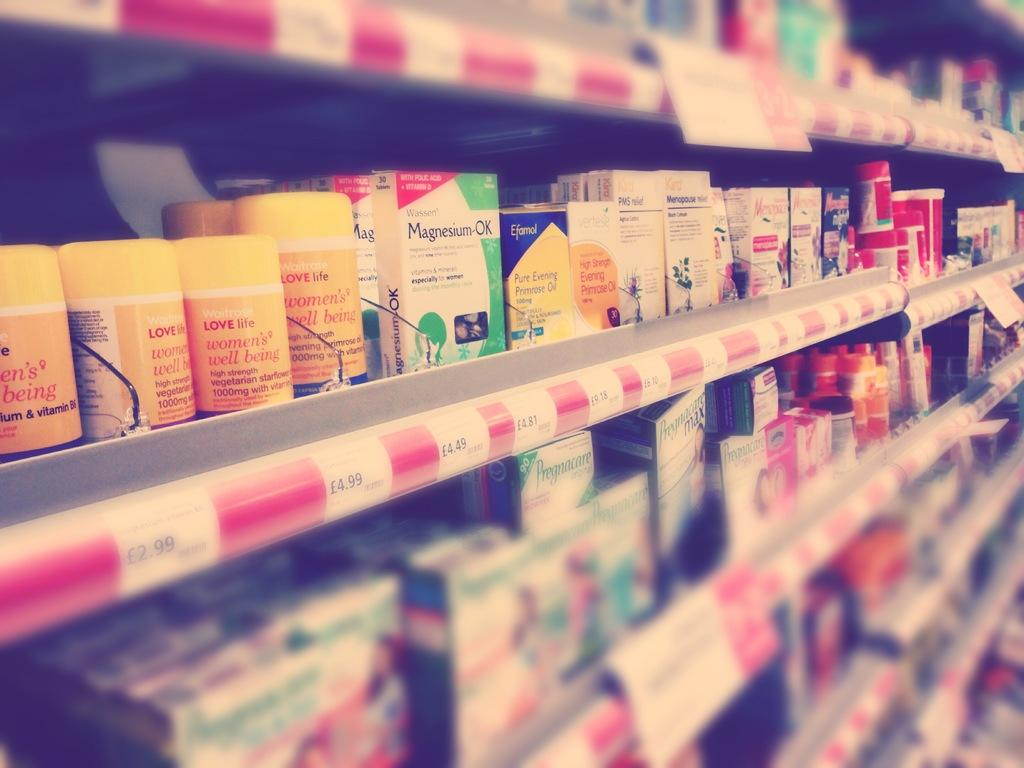Provide a one-sentence caption for the provided image. The shelves with pharmacy products including items called Magnesium-OK. 